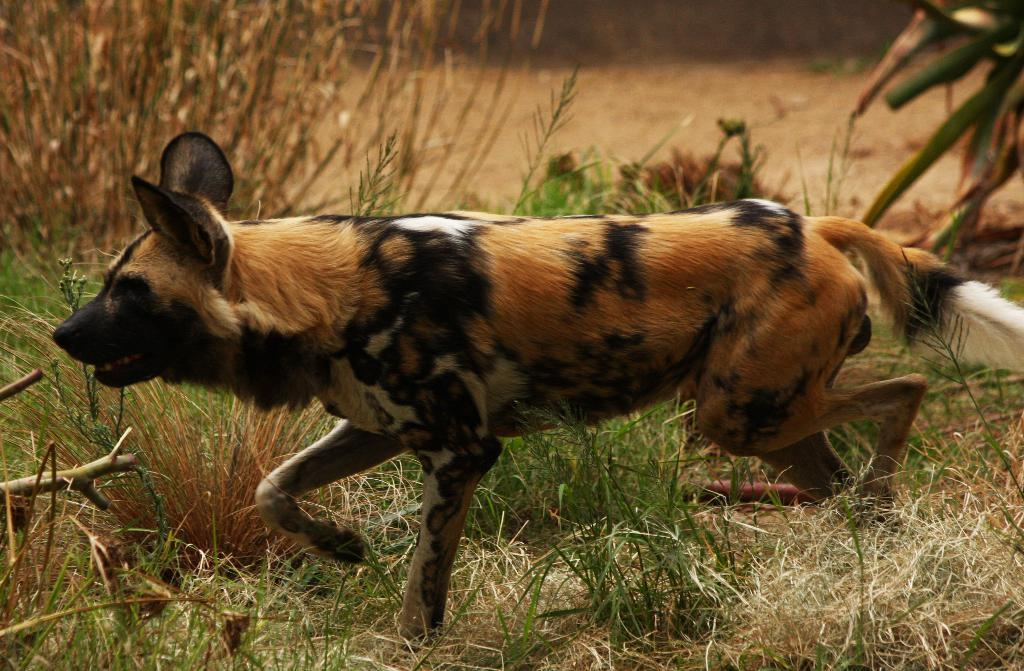What type of animal is in the image? The type of animal cannot be determined from the provided facts. What is the animal doing in the image? The animal is walking on the grass in the image. What can be seen in the background of the image? The ground is visible in the background of the image. What type of spoon is being used to coil the cause in the image? There is no spoon, coil, or cause present in the image. 